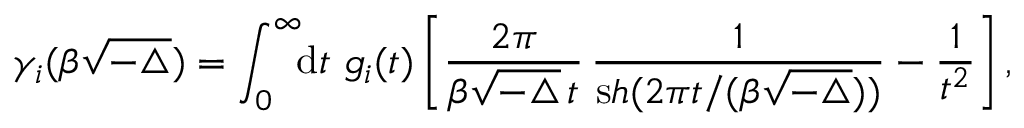Convert formula to latex. <formula><loc_0><loc_0><loc_500><loc_500>\gamma _ { i } ( \beta \sqrt { - \triangle } ) = \int _ { 0 } ^ { \infty } \, { \mathrm d } t \, g _ { i } ( t ) \left [ \frac { 2 \pi } { \beta { \sqrt { - \triangle } } \, t } \, \frac { 1 } { { \mathrm s h } ( 2 \pi t / ( \beta { \sqrt { - \triangle } } ) ) } - \frac { 1 } { t ^ { 2 } } \right ] ,</formula> 